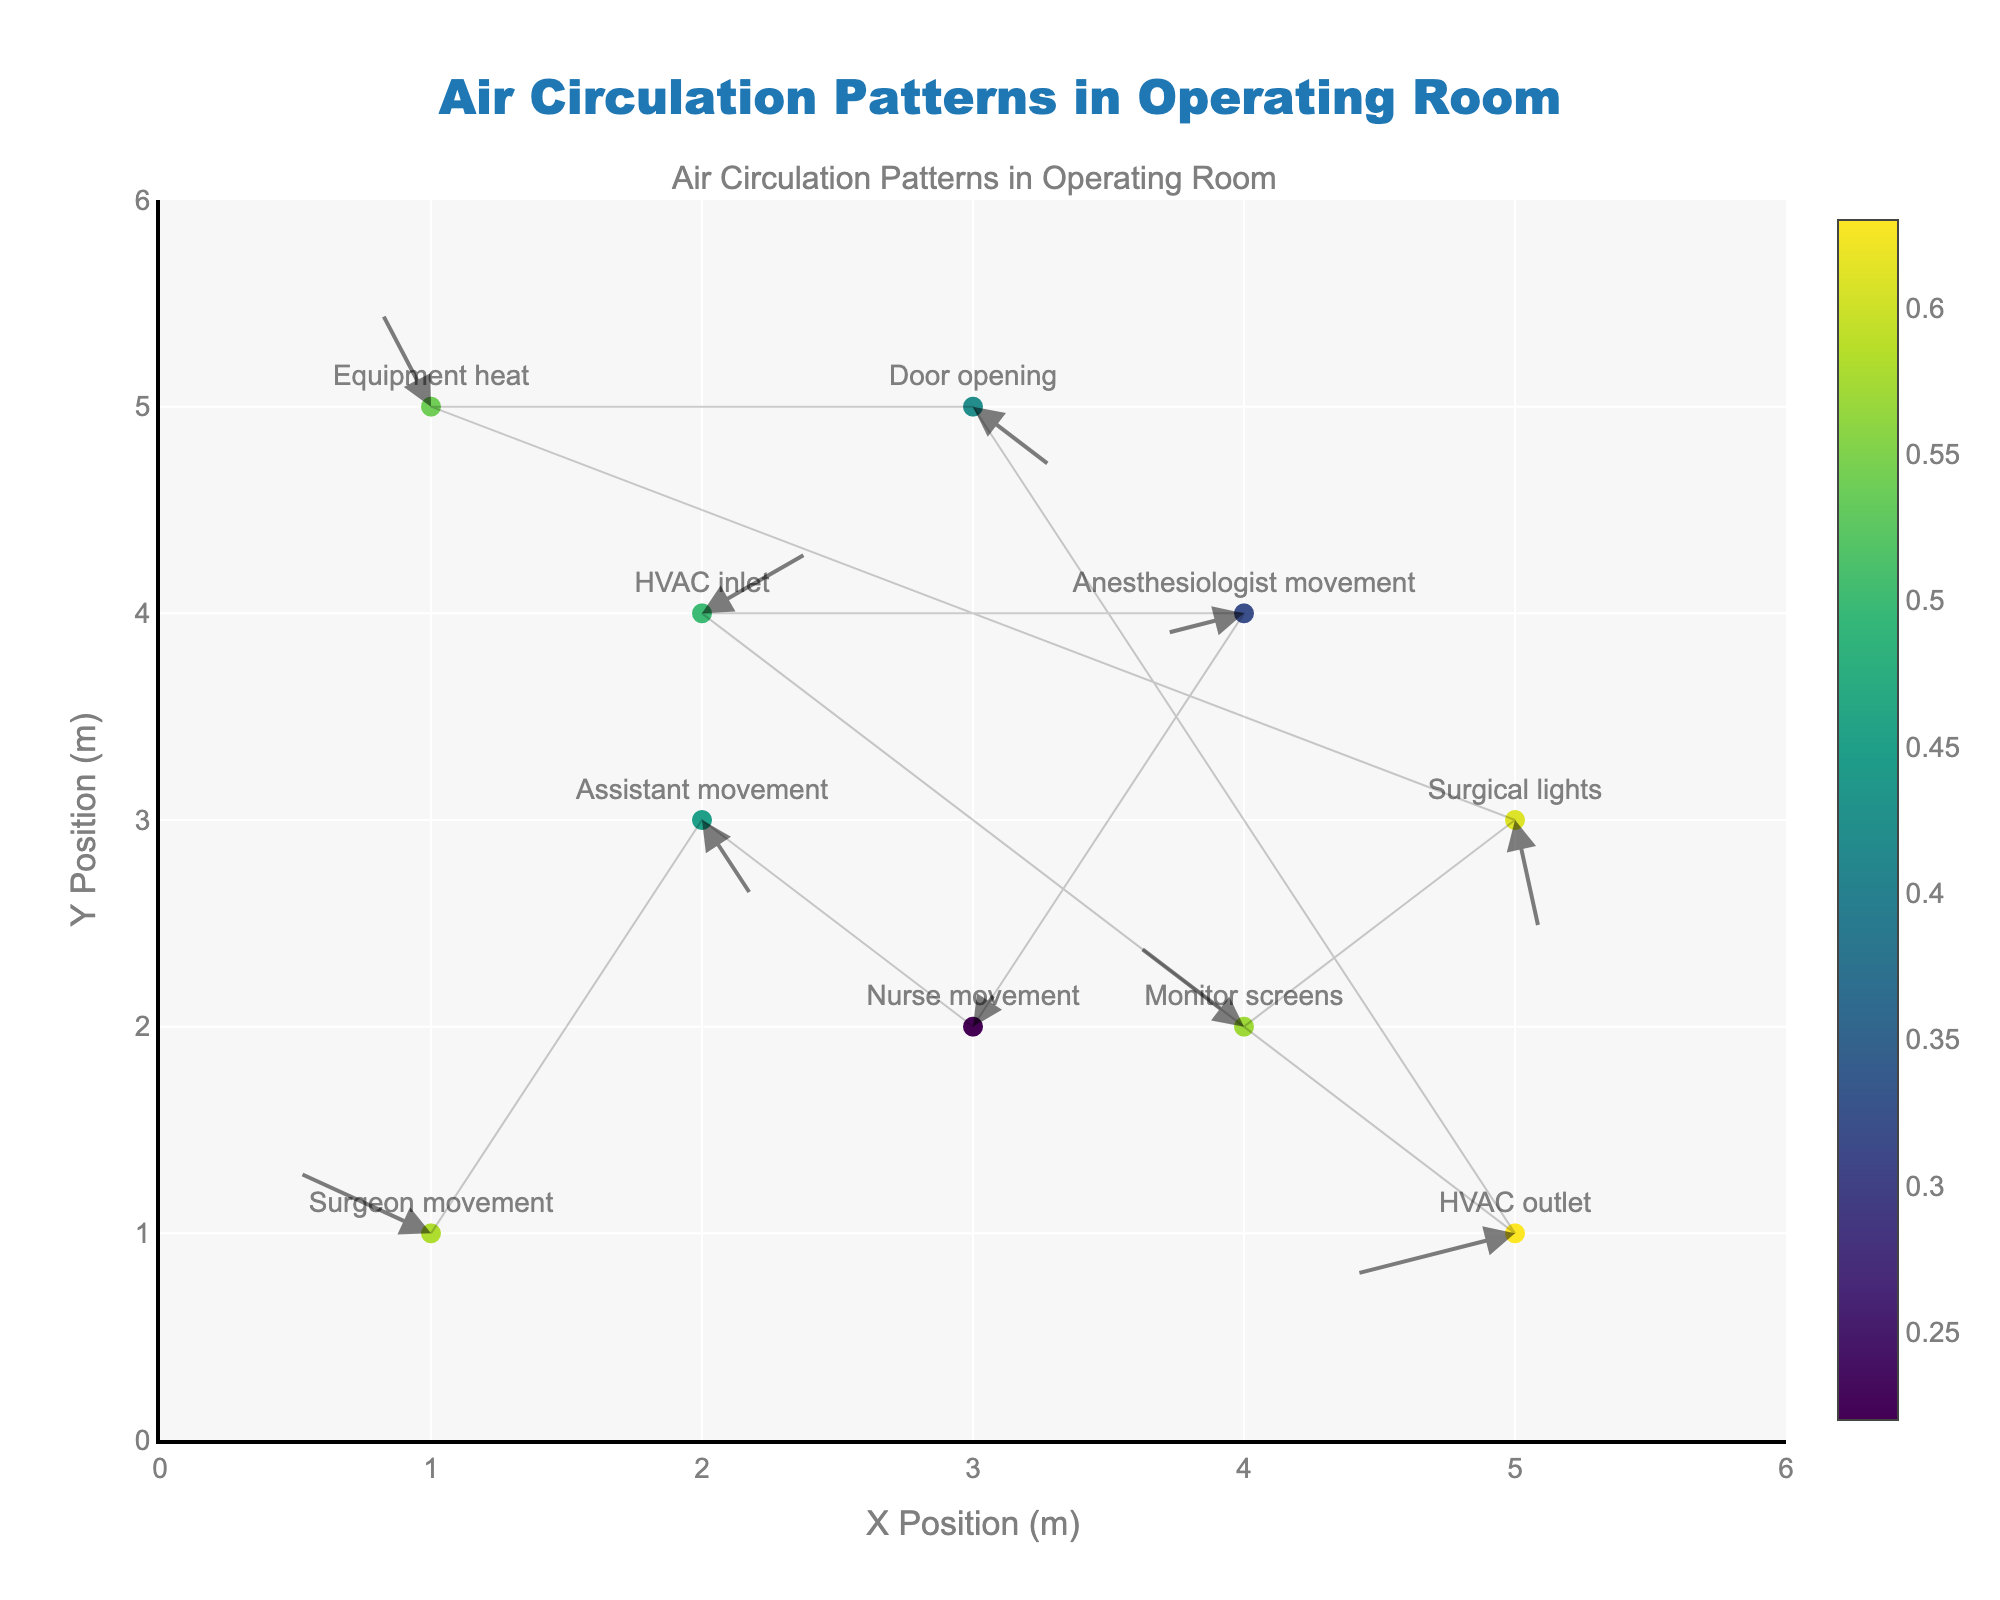How many points are there in the figure in total? By counting all the markers representing each data point
Answer: 10 What is the color range of the markers indicating? The color of the markers represents the magnitude of each movement or flow, with the color scale provided in the figure legend
Answer: Magnitude of movement/flow Which data point has the highest magnitude, and what is its value? By looking at the color scale and the magnitude values listed in the data, the "HVAC outlet" at (5, 1) has the highest magnitude of 0.63
Answer: HVAC outlet, 0.63 Which movements or flows are indicated by arrows pointing to the left (negative u-direction)? Observing the direction of the arrows, the "Surgeon movement" at (1,1), "Anesthesiologist movement" at (4, 4), "HVAC outlet" at (5, 1), and "Monitor screens" at (4, 2) have arrows pointing to the left (negative u-direction)
Answer: Surgeon movement, Anesthesiologist movement, HVAC outlet, Monitor screens Compare the magnitude of "Surgical lights" to "Nurse movement". Which is higher? The magnitude of "Surgical lights" is 0.61 and "Nurse movement" is 0.22, by comparison, "Surgical lights" has a higher magnitude
Answer: Surgical lights How does the airflow direction near the "HVAC inlet" compare to the "Equipment heat"? "HVAC inlet" at (2, 4) has a flow direction to the right and upward (positive u and v), while "Equipment heat" at (1, 5) has a flow direction left and upward (negative u and positive v)
Answer: Different directions; HVAC inlet moves right and up, Equipment heat moves left and up Is the air circulation around the "Assistant movement" predominantly horizontal or vertical? The "Assistant movement" at (2, 3) has a u value (0.2) and v value (-0.4); the v value indicates a stronger vertical component compared to the horizontal component
Answer: Vertical Which movement or flow is closest to the bottom left corner of the room? By comparing the coordinates, the "Surgeon movement" at (1,1) is the closest to the bottom left corner (0,0)
Answer: Surgeon movement How many data points have their arrows pointing upward (positive v-direction)? Observing the direction of the arrows, "Surgeon movement", "Nurse movement", "HVAC inlet", and "Equipment heat" have arrows pointing upward
Answer: 4 If you combine the u-components of "Surgeon movement" and "Surgical lights", what is the result? Adding the u-components of "Surgeon movement" (-0.5) and "Surgical lights" (0.1), the result is -0.4
Answer: -0.4 